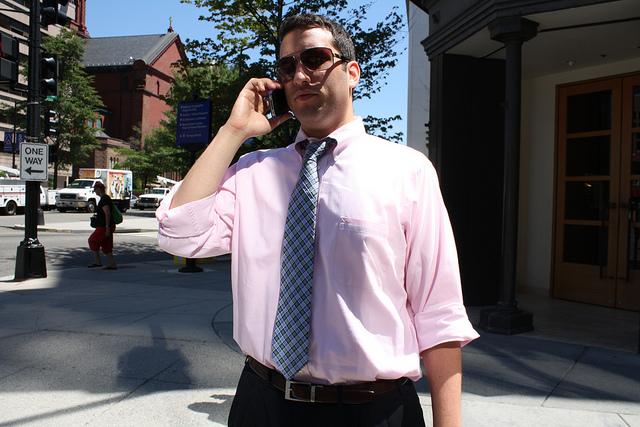Is the one way sign pointing to the right or left of this photo?
Quick response, please. Left. What color is the man's suitcase?
Be succinct. Black. Is the man wearing an official outfit?
Keep it brief. No. Who is the man calling?
Give a very brief answer. Wife. 